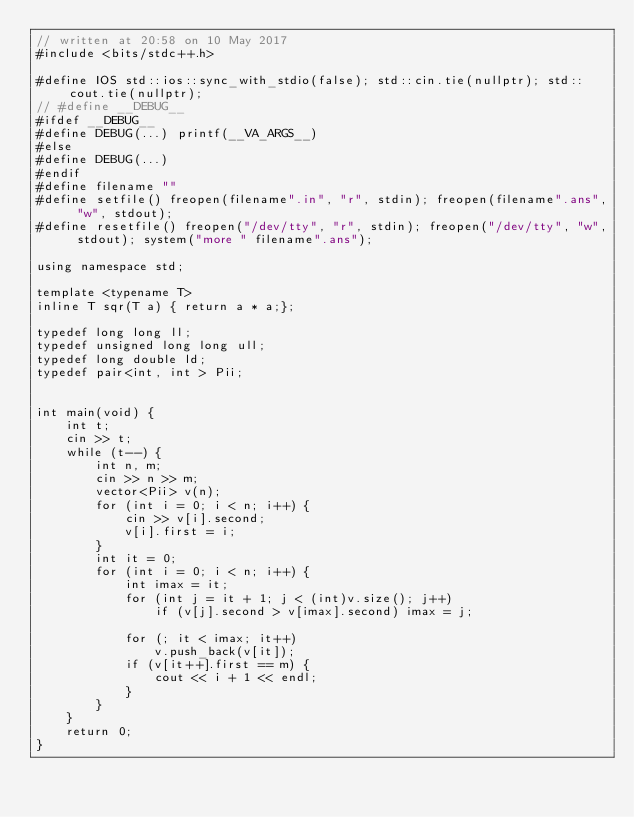Convert code to text. <code><loc_0><loc_0><loc_500><loc_500><_C++_>// written at 20:58 on 10 May 2017
#include <bits/stdc++.h>

#define IOS std::ios::sync_with_stdio(false); std::cin.tie(nullptr); std::cout.tie(nullptr);
// #define __DEBUG__
#ifdef __DEBUG__
#define DEBUG(...) printf(__VA_ARGS__)
#else
#define DEBUG(...)
#endif
#define filename ""
#define setfile() freopen(filename".in", "r", stdin); freopen(filename".ans", "w", stdout);
#define resetfile() freopen("/dev/tty", "r", stdin); freopen("/dev/tty", "w", stdout); system("more " filename".ans");

using namespace std;

template <typename T>
inline T sqr(T a) { return a * a;};

typedef long long ll;
typedef unsigned long long ull;
typedef long double ld;
typedef pair<int, int > Pii;


int main(void) {
    int t;
    cin >> t;
    while (t--) {
        int n, m;
        cin >> n >> m;
        vector<Pii> v(n);
        for (int i = 0; i < n; i++) {
            cin >> v[i].second;
            v[i].first = i;
        }
        int it = 0;
        for (int i = 0; i < n; i++) {
            int imax = it;
            for (int j = it + 1; j < (int)v.size(); j++)
                if (v[j].second > v[imax].second) imax = j;

            for (; it < imax; it++)
                v.push_back(v[it]);
            if (v[it++].first == m) {
                cout << i + 1 << endl;
            }
        }
    }
    return 0;
}
</code> 